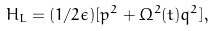Convert formula to latex. <formula><loc_0><loc_0><loc_500><loc_500>H _ { L } = ( 1 / 2 \epsilon ) [ p ^ { 2 } + \Omega ^ { 2 } ( t ) q ^ { 2 } ] ,</formula> 